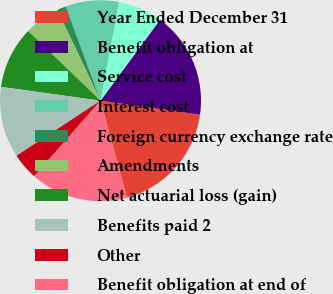<chart> <loc_0><loc_0><loc_500><loc_500><pie_chart><fcel>Year Ended December 31<fcel>Benefit obligation at<fcel>Service cost<fcel>Interest cost<fcel>Foreign currency exchange rate<fcel>Amendments<fcel>Net actuarial loss (gain)<fcel>Benefits paid 2<fcel>Other<fcel>Benefit obligation at end of<nl><fcel>18.55%<fcel>17.13%<fcel>7.15%<fcel>8.57%<fcel>1.45%<fcel>5.72%<fcel>10.0%<fcel>11.43%<fcel>4.3%<fcel>15.7%<nl></chart> 